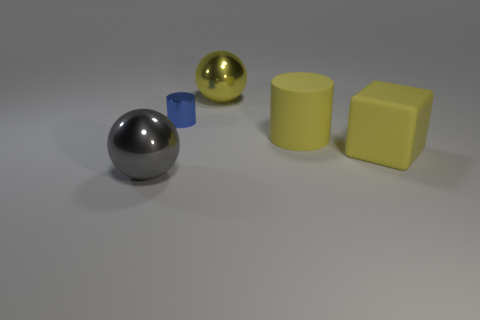How many matte things are big yellow balls or cylinders?
Your answer should be very brief. 1. Is there a tiny purple metallic thing?
Offer a terse response. No. Is the shape of the gray thing the same as the small blue thing?
Keep it short and to the point. No. There is a large metal ball that is in front of the large metallic thing right of the tiny blue cylinder; what number of yellow matte cylinders are left of it?
Make the answer very short. 0. The large object that is to the left of the large cylinder and right of the small cylinder is made of what material?
Provide a short and direct response. Metal. What is the color of the big thing that is in front of the large matte cylinder and to the left of the large yellow cube?
Offer a very short reply. Gray. Are there any other things of the same color as the rubber block?
Give a very brief answer. Yes. There is a big metallic thing right of the large shiny sphere to the left of the cylinder that is left of the rubber cylinder; what shape is it?
Your response must be concise. Sphere. There is a large thing that is the same shape as the small blue object; what color is it?
Your response must be concise. Yellow. There is a large metal ball behind the large sphere that is in front of the yellow shiny sphere; what color is it?
Keep it short and to the point. Yellow. 